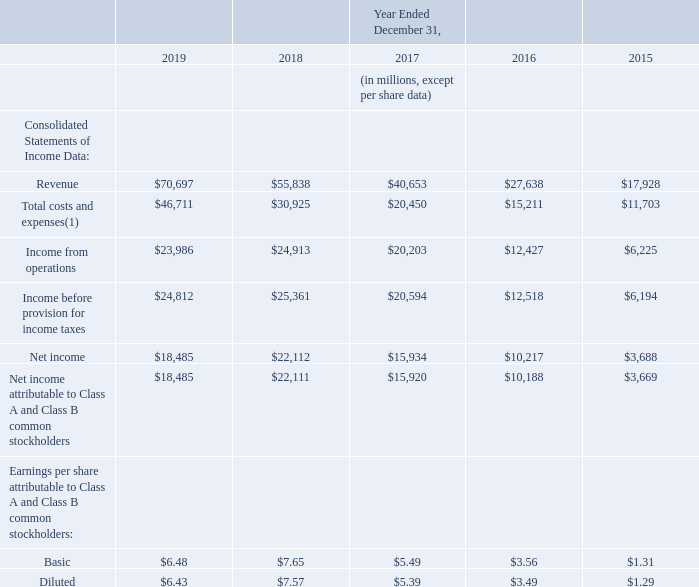Item 6. Selected Financial Data
You should read the following selected consolidated financial data in conjunction with Part II, Item 7, "Management's Discussion and Analysis of Financial Condition and Results of Operations," and our consolidated financial statements and the related notes included in Part II, Item 8, "Financial Statements and Supplementary Data" of this Annual Report on Form 10-K.
The consolidated statements of income data for each of the years ended December 31, 2019, 2018, and 2017 and the consolidated balance sheets data as of December 31, 2019 and 2018 are derived from our audited consolidated financial statements included in Part II, Item 8, "Financial Statements and Supplementary Data" of this Annual Report on Form 10-K. The consolidated statements of income data for the years ended December 31, 2016 and 2015 and the consolidated balance sheets data as of December 31, 2017, 2016, and 2015 are derived from our audited consolidated financial statements, except as otherwise noted, that are not included in this Annual Report on Form 10-K. Our historical results are not necessarily indicative of our results in any future period.
(1) Total costs and expenses include 4,840 million, 4,150 million, 3,720 million, 3,220 million, and 2,970 million of share-based compensation for the years ended December 31, 2019, 2018, 2017, 2016, and 2015, respectively.
What is the revenue for 2019 and 2018 respectively?
Answer scale should be: million. $70,697, $55,838. What is the Income from operations for 2019 and 2018 respectively?
Answer scale should be: million. $23,986, $24,913. What is the Net income for 2019 and 2018 respectively?
Answer scale should be: million. $18,485, $22,112. What is the change in revenue between 2018 and 2019?
Answer scale should be: million. 70,697-55,838
Answer: 14859. What is the average revenue for 2018 and 2019?
Answer scale should be: million. (70,697+ 55,838)/2
Answer: 63267.5. Which year has the highest amount of revenue? 70,697> 55,838> 40,653> 27,638> 17,928
Answer: 2019. 